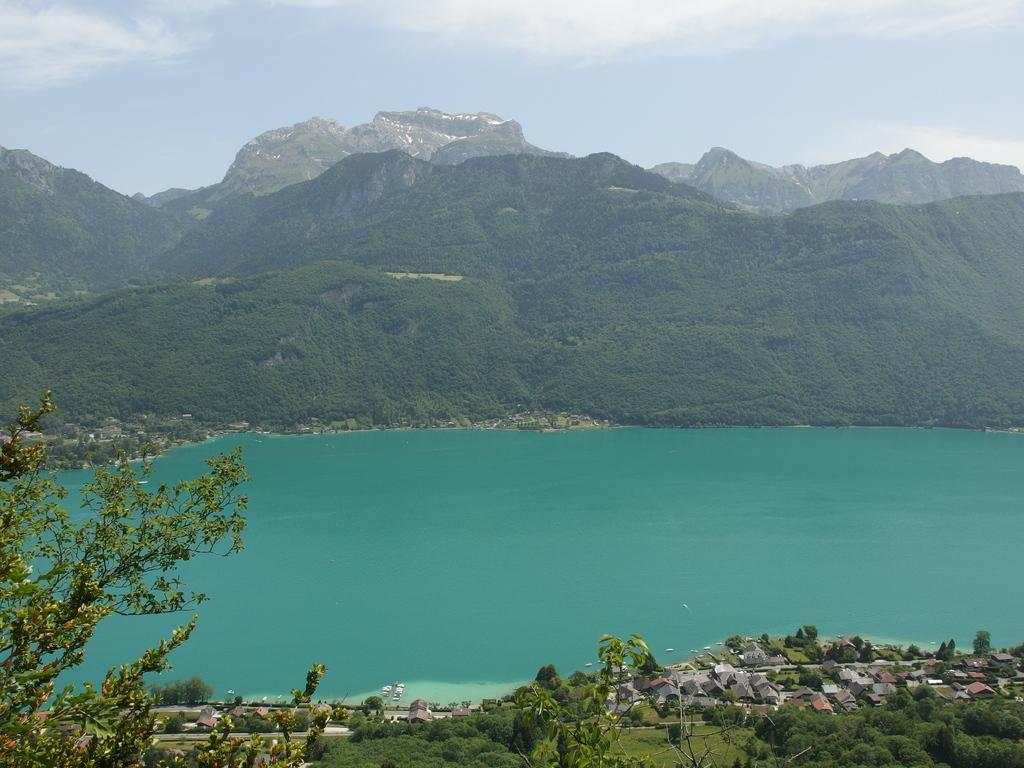What type of structures can be seen in the image? There are houses in the image. What other natural elements are present in the image? There are trees and water visible in the image. What can be seen in the background of the image? There are mountains and the sky visible in the background of the image. Can you see anyone using an umbrella in the image? There is no umbrella present in the image. Is there a bath visible in the image? There is no bath present in the image. 